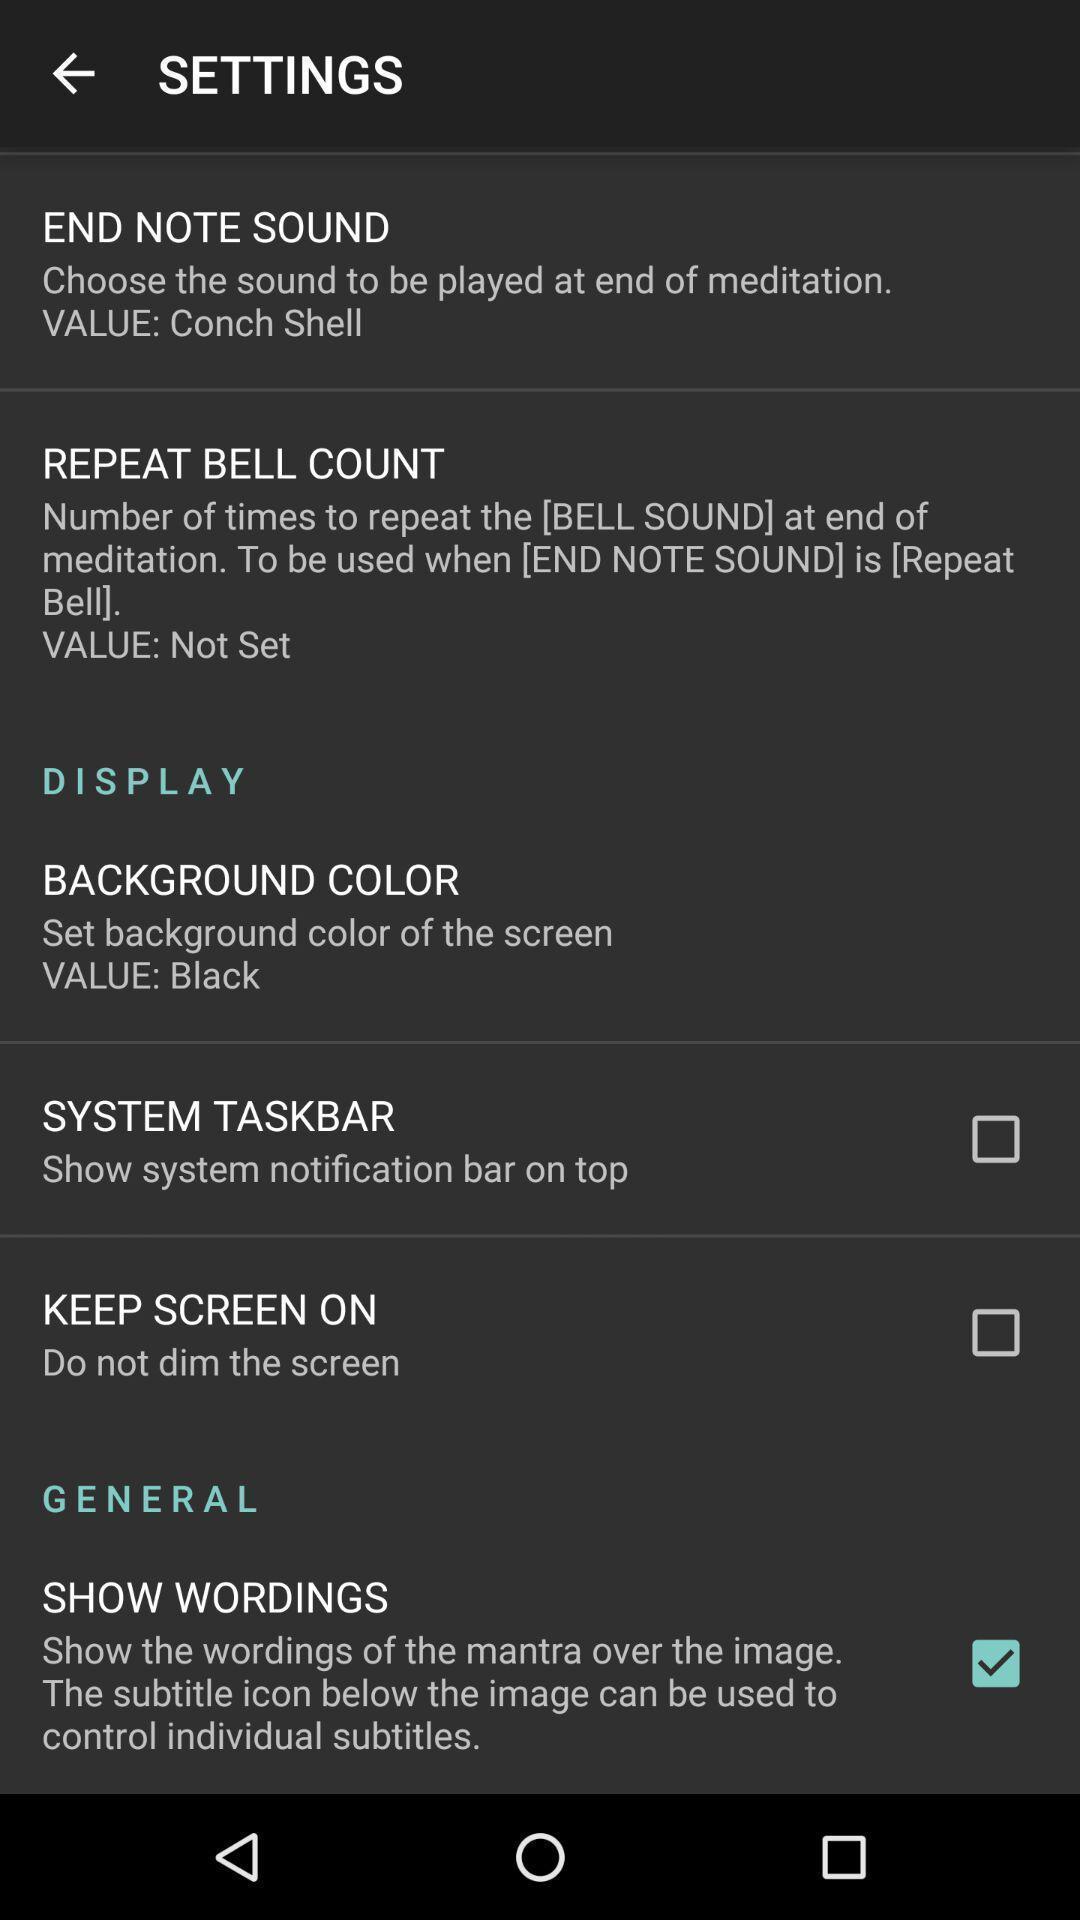Summarize the information in this screenshot. Page showing different setting options on an app. 